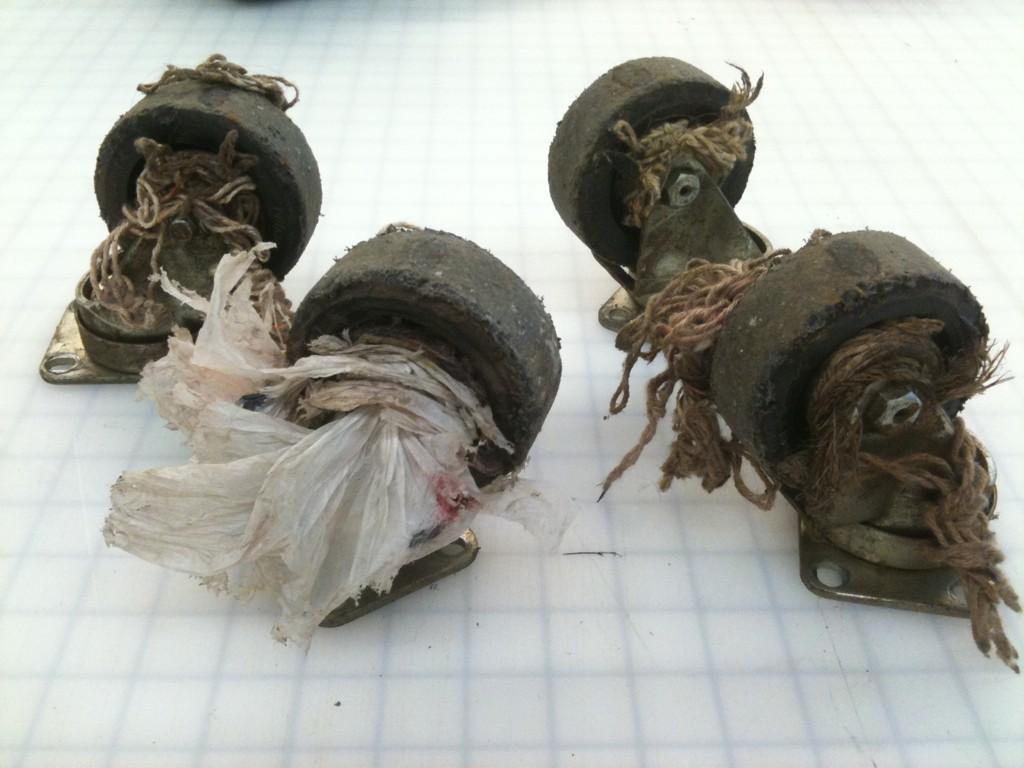Can you describe this image briefly? In this image we can see some objects placed on the surface. 